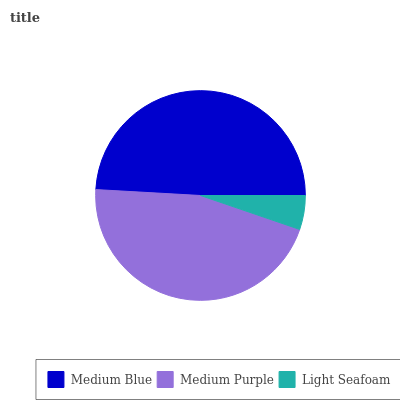Is Light Seafoam the minimum?
Answer yes or no. Yes. Is Medium Blue the maximum?
Answer yes or no. Yes. Is Medium Purple the minimum?
Answer yes or no. No. Is Medium Purple the maximum?
Answer yes or no. No. Is Medium Blue greater than Medium Purple?
Answer yes or no. Yes. Is Medium Purple less than Medium Blue?
Answer yes or no. Yes. Is Medium Purple greater than Medium Blue?
Answer yes or no. No. Is Medium Blue less than Medium Purple?
Answer yes or no. No. Is Medium Purple the high median?
Answer yes or no. Yes. Is Medium Purple the low median?
Answer yes or no. Yes. Is Light Seafoam the high median?
Answer yes or no. No. Is Medium Blue the low median?
Answer yes or no. No. 